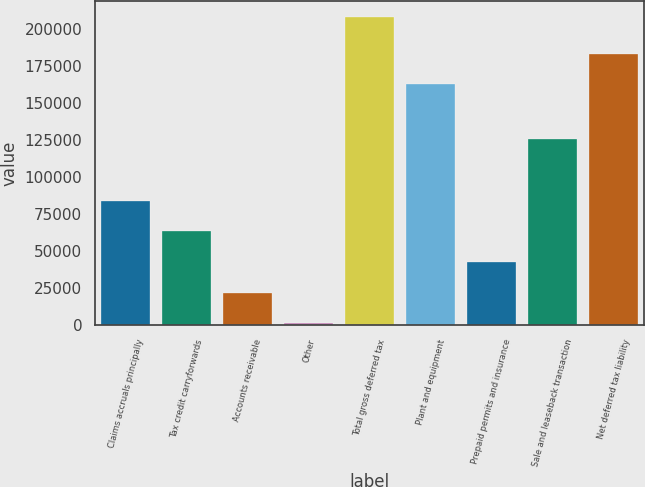Convert chart to OTSL. <chart><loc_0><loc_0><loc_500><loc_500><bar_chart><fcel>Claims accruals principally<fcel>Tax credit carryforwards<fcel>Accounts receivable<fcel>Other<fcel>Total gross deferred tax<fcel>Plant and equipment<fcel>Prepaid permits and insurance<fcel>Sale and leaseback transaction<fcel>Net deferred tax liability<nl><fcel>83926<fcel>63261<fcel>21931<fcel>1266<fcel>207916<fcel>162406<fcel>42596<fcel>125256<fcel>183071<nl></chart> 